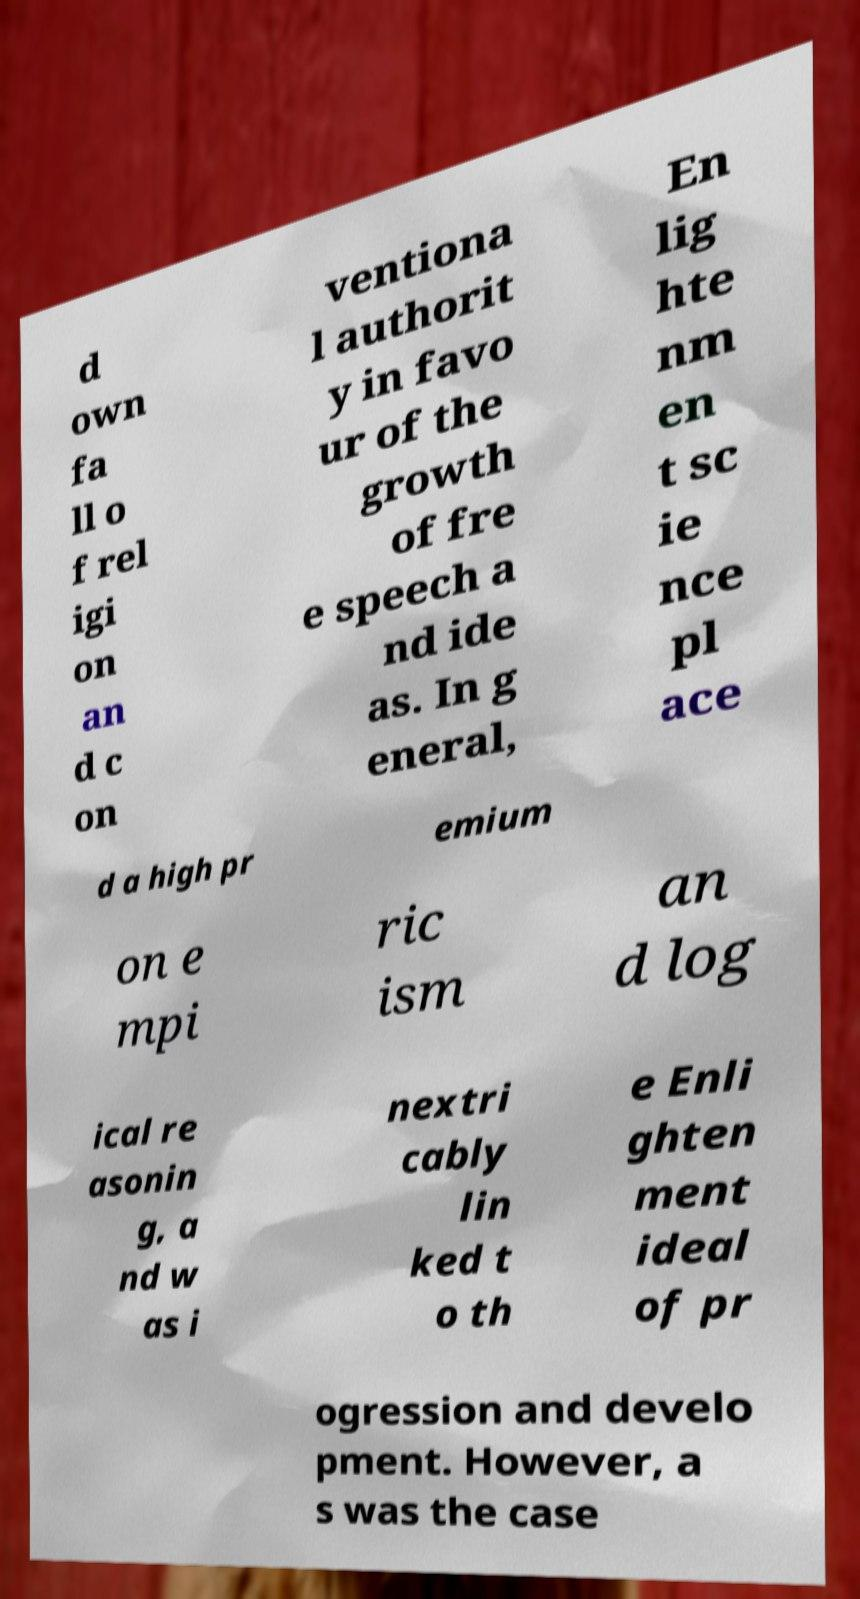Please read and relay the text visible in this image. What does it say? d own fa ll o f rel igi on an d c on ventiona l authorit y in favo ur of the growth of fre e speech a nd ide as. In g eneral, En lig hte nm en t sc ie nce pl ace d a high pr emium on e mpi ric ism an d log ical re asonin g, a nd w as i nextri cably lin ked t o th e Enli ghten ment ideal of pr ogression and develo pment. However, a s was the case 